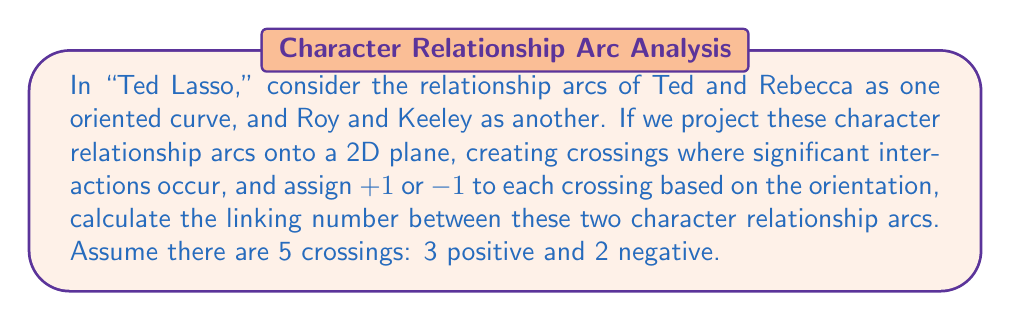Could you help me with this problem? To calculate the linking number between two character relationship arcs in "Ted Lasso," we'll follow these steps:

1. Understand the concept: The linking number is a topological invariant that measures how two curves are linked in three-dimensional space. In this case, we're treating character relationships as curves.

2. Identify crossings: We've been given that there are 5 crossings between the Ted-Rebecca arc and the Roy-Keeley arc when projected onto a 2D plane.

3. Assign values to crossings: Each crossing is assigned a value of +1 or -1 based on its orientation. We're told that there are 3 positive crossings and 2 negative crossings.

4. Apply the linking number formula: The linking number is calculated as half the sum of the crossing values.

   $$\text{Linking Number} = \frac{1}{2} \sum \text{(Crossing Values)}$$

5. Calculate:
   $$\text{Linking Number} = \frac{1}{2} (3 \times (+1) + 2 \times (-1))$$
   $$= \frac{1}{2} (3 - 2)$$
   $$= \frac{1}{2} (1)$$
   $$= \frac{1}{2}$$

Thus, the linking number between the Ted-Rebecca and Roy-Keeley relationship arcs is 1/2.
Answer: $\frac{1}{2}$ 